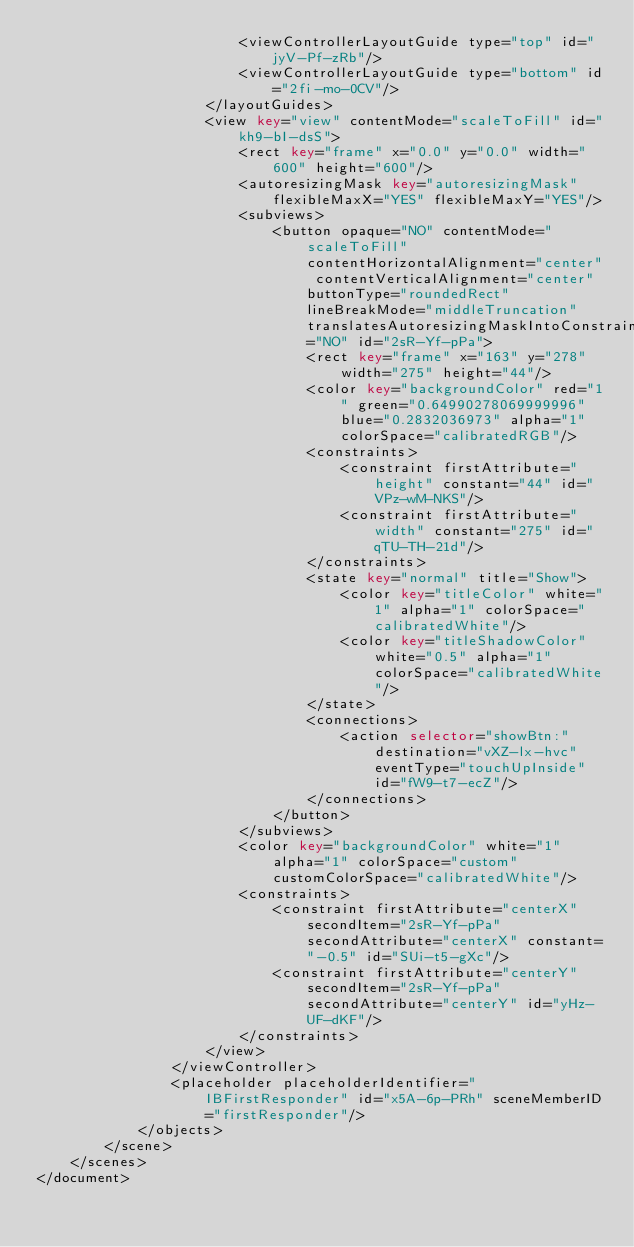<code> <loc_0><loc_0><loc_500><loc_500><_XML_>                        <viewControllerLayoutGuide type="top" id="jyV-Pf-zRb"/>
                        <viewControllerLayoutGuide type="bottom" id="2fi-mo-0CV"/>
                    </layoutGuides>
                    <view key="view" contentMode="scaleToFill" id="kh9-bI-dsS">
                        <rect key="frame" x="0.0" y="0.0" width="600" height="600"/>
                        <autoresizingMask key="autoresizingMask" flexibleMaxX="YES" flexibleMaxY="YES"/>
                        <subviews>
                            <button opaque="NO" contentMode="scaleToFill" contentHorizontalAlignment="center" contentVerticalAlignment="center" buttonType="roundedRect" lineBreakMode="middleTruncation" translatesAutoresizingMaskIntoConstraints="NO" id="2sR-Yf-pPa">
                                <rect key="frame" x="163" y="278" width="275" height="44"/>
                                <color key="backgroundColor" red="1" green="0.64990278069999996" blue="0.2832036973" alpha="1" colorSpace="calibratedRGB"/>
                                <constraints>
                                    <constraint firstAttribute="height" constant="44" id="VPz-wM-NKS"/>
                                    <constraint firstAttribute="width" constant="275" id="qTU-TH-21d"/>
                                </constraints>
                                <state key="normal" title="Show">
                                    <color key="titleColor" white="1" alpha="1" colorSpace="calibratedWhite"/>
                                    <color key="titleShadowColor" white="0.5" alpha="1" colorSpace="calibratedWhite"/>
                                </state>
                                <connections>
                                    <action selector="showBtn:" destination="vXZ-lx-hvc" eventType="touchUpInside" id="fW9-t7-ecZ"/>
                                </connections>
                            </button>
                        </subviews>
                        <color key="backgroundColor" white="1" alpha="1" colorSpace="custom" customColorSpace="calibratedWhite"/>
                        <constraints>
                            <constraint firstAttribute="centerX" secondItem="2sR-Yf-pPa" secondAttribute="centerX" constant="-0.5" id="SUi-t5-gXc"/>
                            <constraint firstAttribute="centerY" secondItem="2sR-Yf-pPa" secondAttribute="centerY" id="yHz-UF-dKF"/>
                        </constraints>
                    </view>
                </viewController>
                <placeholder placeholderIdentifier="IBFirstResponder" id="x5A-6p-PRh" sceneMemberID="firstResponder"/>
            </objects>
        </scene>
    </scenes>
</document>
</code> 